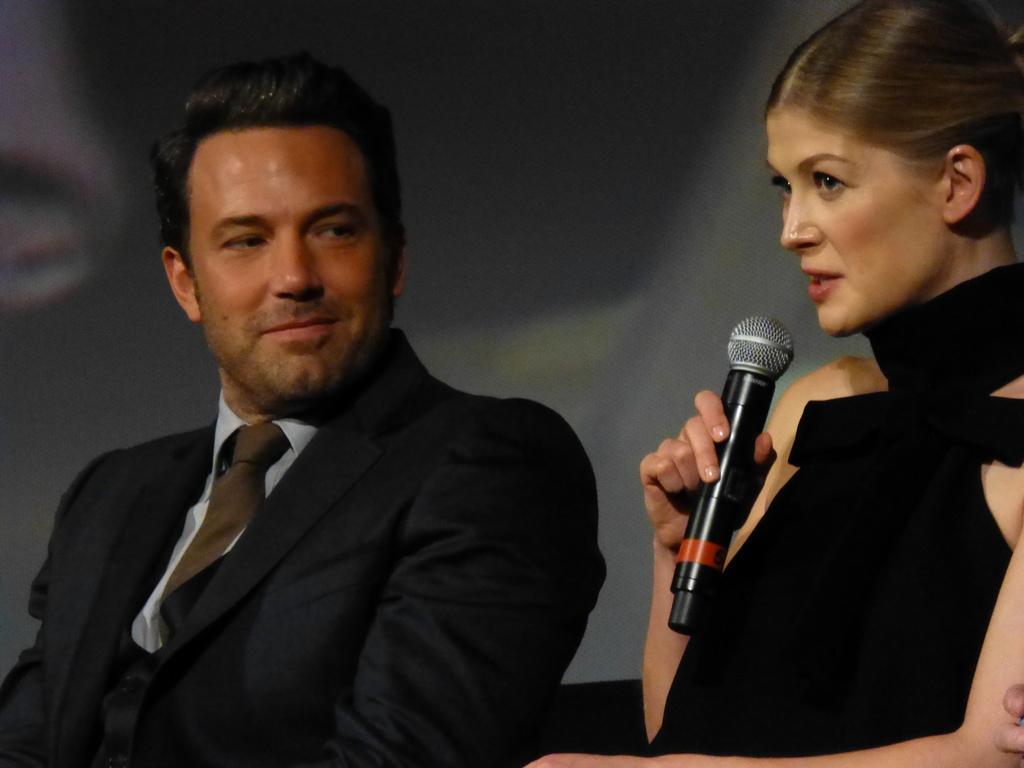How would you summarize this image in a sentence or two? This picture shows a man and woman seated on the chairs and a women speaking with the help of a microphone 